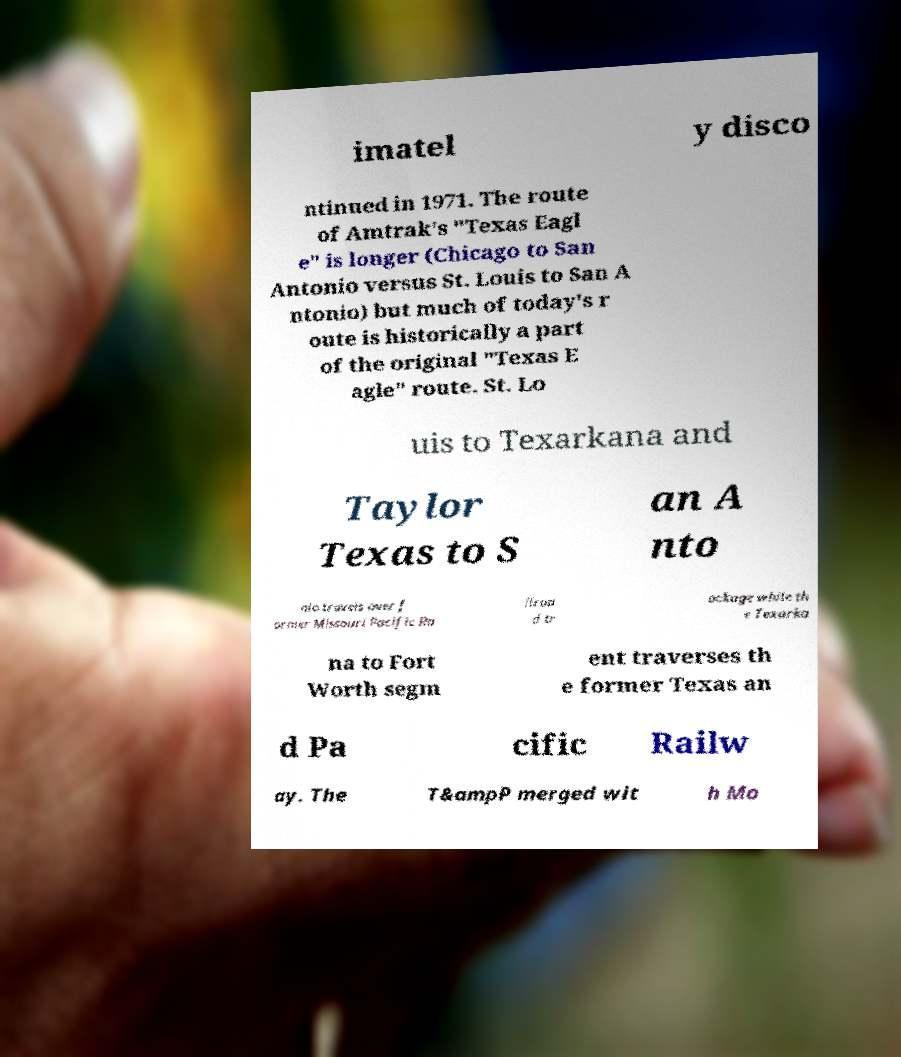Could you extract and type out the text from this image? imatel y disco ntinued in 1971. The route of Amtrak's "Texas Eagl e" is longer (Chicago to San Antonio versus St. Louis to San A ntonio) but much of today's r oute is historically a part of the original "Texas E agle" route. St. Lo uis to Texarkana and Taylor Texas to S an A nto nio travels over f ormer Missouri Pacific Ra ilroa d tr ackage while th e Texarka na to Fort Worth segm ent traverses th e former Texas an d Pa cific Railw ay. The T&ampP merged wit h Mo 